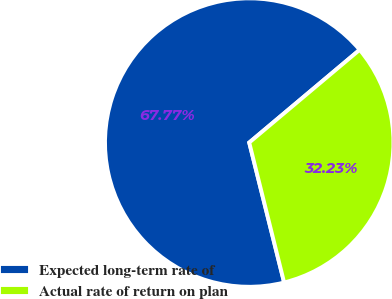Convert chart to OTSL. <chart><loc_0><loc_0><loc_500><loc_500><pie_chart><fcel>Expected long-term rate of<fcel>Actual rate of return on plan<nl><fcel>67.77%<fcel>32.23%<nl></chart> 